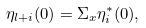Convert formula to latex. <formula><loc_0><loc_0><loc_500><loc_500>\eta _ { l + i } ( 0 ) = \Sigma _ { x } \eta _ { i } ^ { \ast } ( 0 ) ,</formula> 